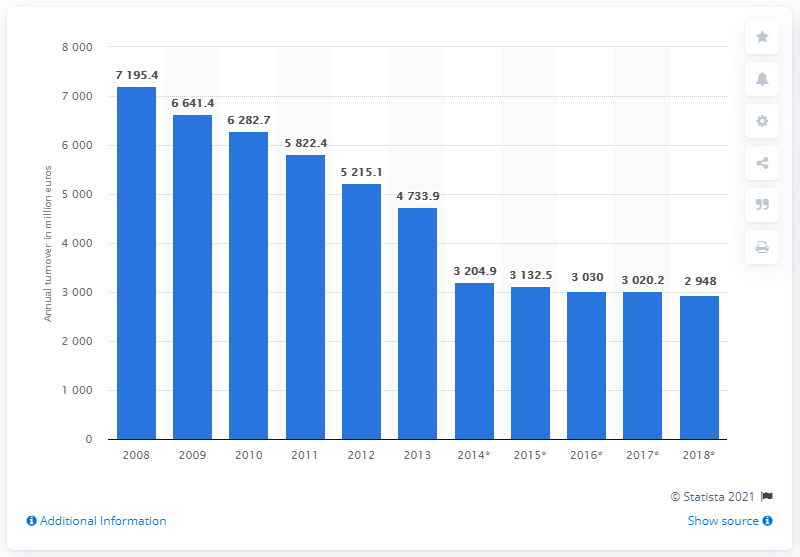Give some essential details in this illustration. In 2018, the total turnover of food, beverage, and tobacco stores in Greece was 2948. 